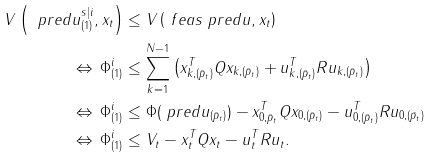Convert formula to latex. <formula><loc_0><loc_0><loc_500><loc_500>V \left ( \ p r e d { u } ^ { s | i } _ { ( 1 ) } , x _ { t } \right ) & \leq V \left ( \ f e a s { \ p r e d { u } } , x _ { t } \right ) \\ \Leftrightarrow \, \Phi ^ { i } _ { ( 1 ) } & \leq \sum _ { k = 1 } ^ { N - 1 } \left ( x _ { k , ( \bar { p } _ { t } ) } ^ { T } Q x _ { k , ( \bar { p } _ { t } ) } + u _ { k , ( \bar { p } _ { t } ) } ^ { T } R u _ { k , ( \bar { p } _ { t } ) } \right ) \\ \Leftrightarrow \, \Phi ^ { i } _ { ( 1 ) } & \leq \Phi ( \ p r e d { u } _ { ( \bar { p } _ { t } ) } ) - x _ { 0 , \bar { p } _ { t } } ^ { T } Q x _ { 0 , ( \bar { p } _ { t } ) } - u _ { 0 , ( \bar { p } _ { t } ) } ^ { T } R u _ { 0 , ( \bar { p } _ { t } ) } \\ \Leftrightarrow \, \Phi ^ { i } _ { ( 1 ) } & \leq V _ { t } - x _ { t } ^ { T } Q x _ { t } - u _ { t } ^ { T } R u _ { t } .</formula> 